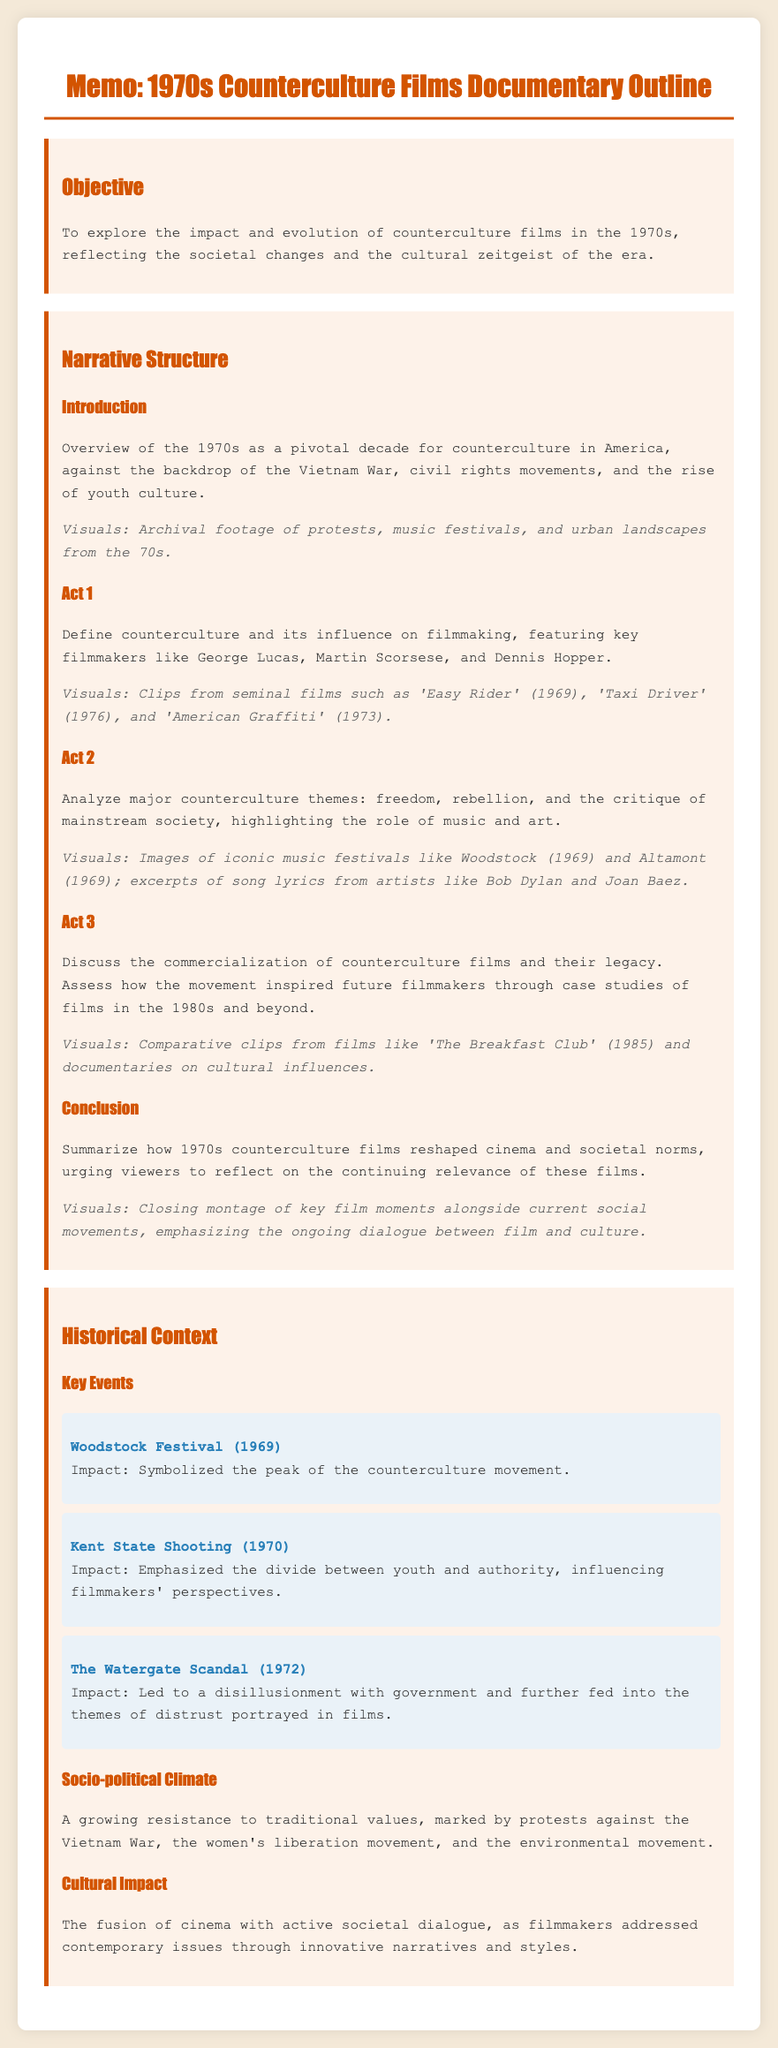what is the objective of the documentary? The objective is to explore the impact and evolution of counterculture films in the 1970s, reflecting the societal changes and the cultural zeitgeist of the era.
Answer: To explore the impact and evolution of counterculture films in the 1970s who is featured in Act 1 as key filmmakers? The document mentions key filmmakers like George Lucas, Martin Scorsese, and Dennis Hopper in Act 1.
Answer: George Lucas, Martin Scorsese, Dennis Hopper which festival symbolized the peak of the counterculture movement? The document states that the Woodstock Festival in 1969 symbolized the peak of the counterculture movement.
Answer: Woodstock Festival (1969) what major event in 1970 emphasized the divide between youth and authority? The Kent State Shooting in 1970 is noted for emphasizing the divide between youth and authority.
Answer: Kent State Shooting (1970) which film released in 1976 is mentioned in Act 1? Act 1 features clips from 'Taxi Driver' (1976) as a seminal film.
Answer: Taxi Driver (1976) what themes are analyzed in Act 2 of the documentary? Act 2 analyzes themes of freedom, rebellion, and the critique of mainstream society.
Answer: Freedom, rebellion, critique of mainstream society how does the document describe the socio-political climate of the 1970s? The socio-political climate is described as a growing resistance to traditional values.
Answer: Growing resistance to traditional values what is the conclusion’s main focus in the documentary outline? The conclusion summarizes how 1970s counterculture films reshaped cinema and societal norms.
Answer: How 1970s counterculture films reshaped cinema and societal norms 